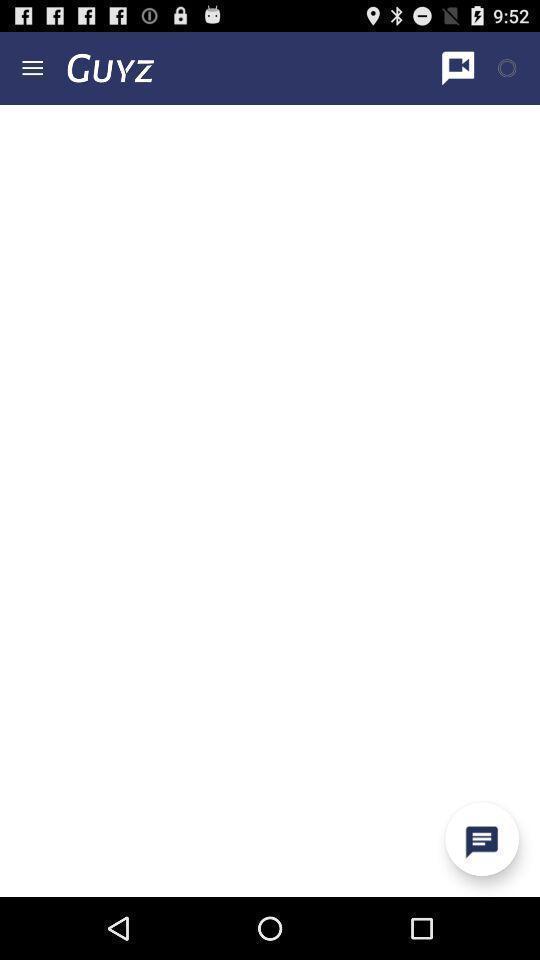Explain the elements present in this screenshot. Screen displaying the blank page. 